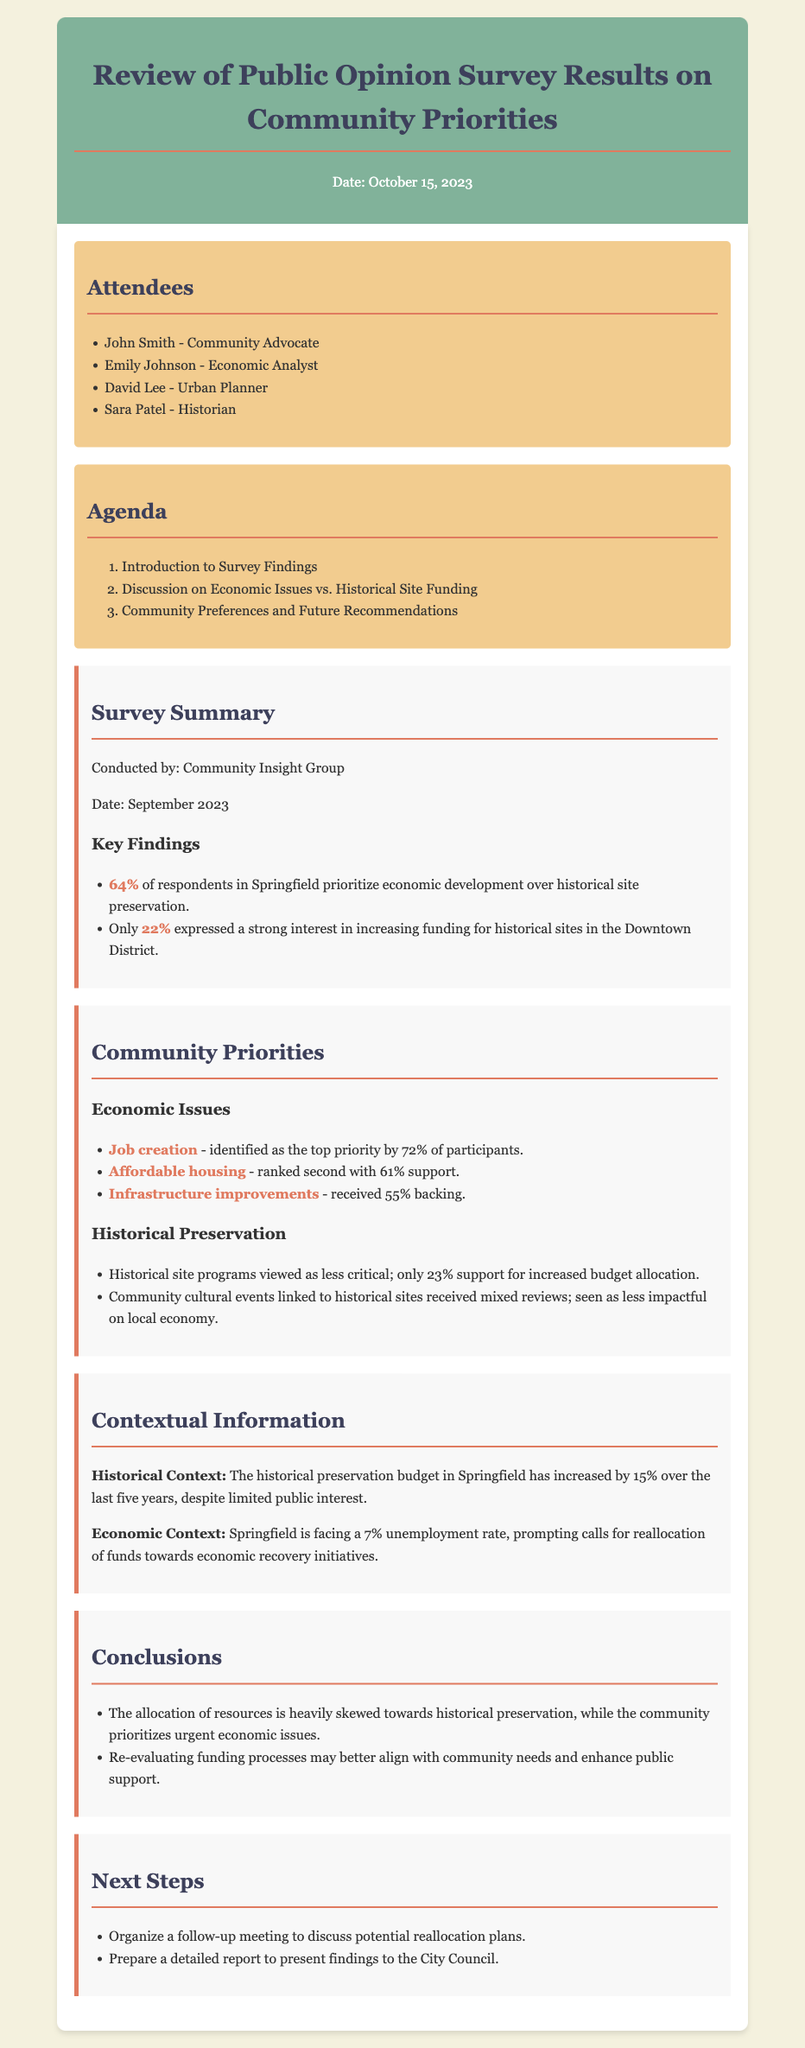What percentage of respondents prioritize economic development? The document states that 64% of respondents in Springfield prioritize economic development.
Answer: 64% What is the second-ranked community priority according to participants? From the document, affordable housing is ranked second with 61% support.
Answer: Affordable housing How much has the historical preservation budget increased over the last five years? The document mentions that the historical preservation budget has increased by 15% over the last five years.
Answer: 15% What is the unemployment rate mentioned in the document? The economic context section indicates that Springfield is facing a 7% unemployment rate.
Answer: 7% Who conducted the public opinion survey? The document credits the Community Insight Group for conducting the survey.
Answer: Community Insight Group What percentage of participants supported increased budget allocation for historical site programs? The document indicates that only 23% support increased budget allocation for historical site programs.
Answer: 23% What is the significance of cultural events linked to historical sites according to the community? The document states that community cultural events linked to historical sites received mixed reviews and are seen as less impactful on the local economy.
Answer: Less impactful What are the next steps listed in the document? The next steps include organizing a follow-up meeting and preparing a detailed report to present findings to the City Council.
Answer: Organize a follow-up meeting and prepare a report What is the main conclusion regarding resource allocation? The document concludes that resource allocation is heavily skewed towards historical preservation while the community prioritizes urgent economic issues.
Answer: Heavily skewed towards historical preservation 